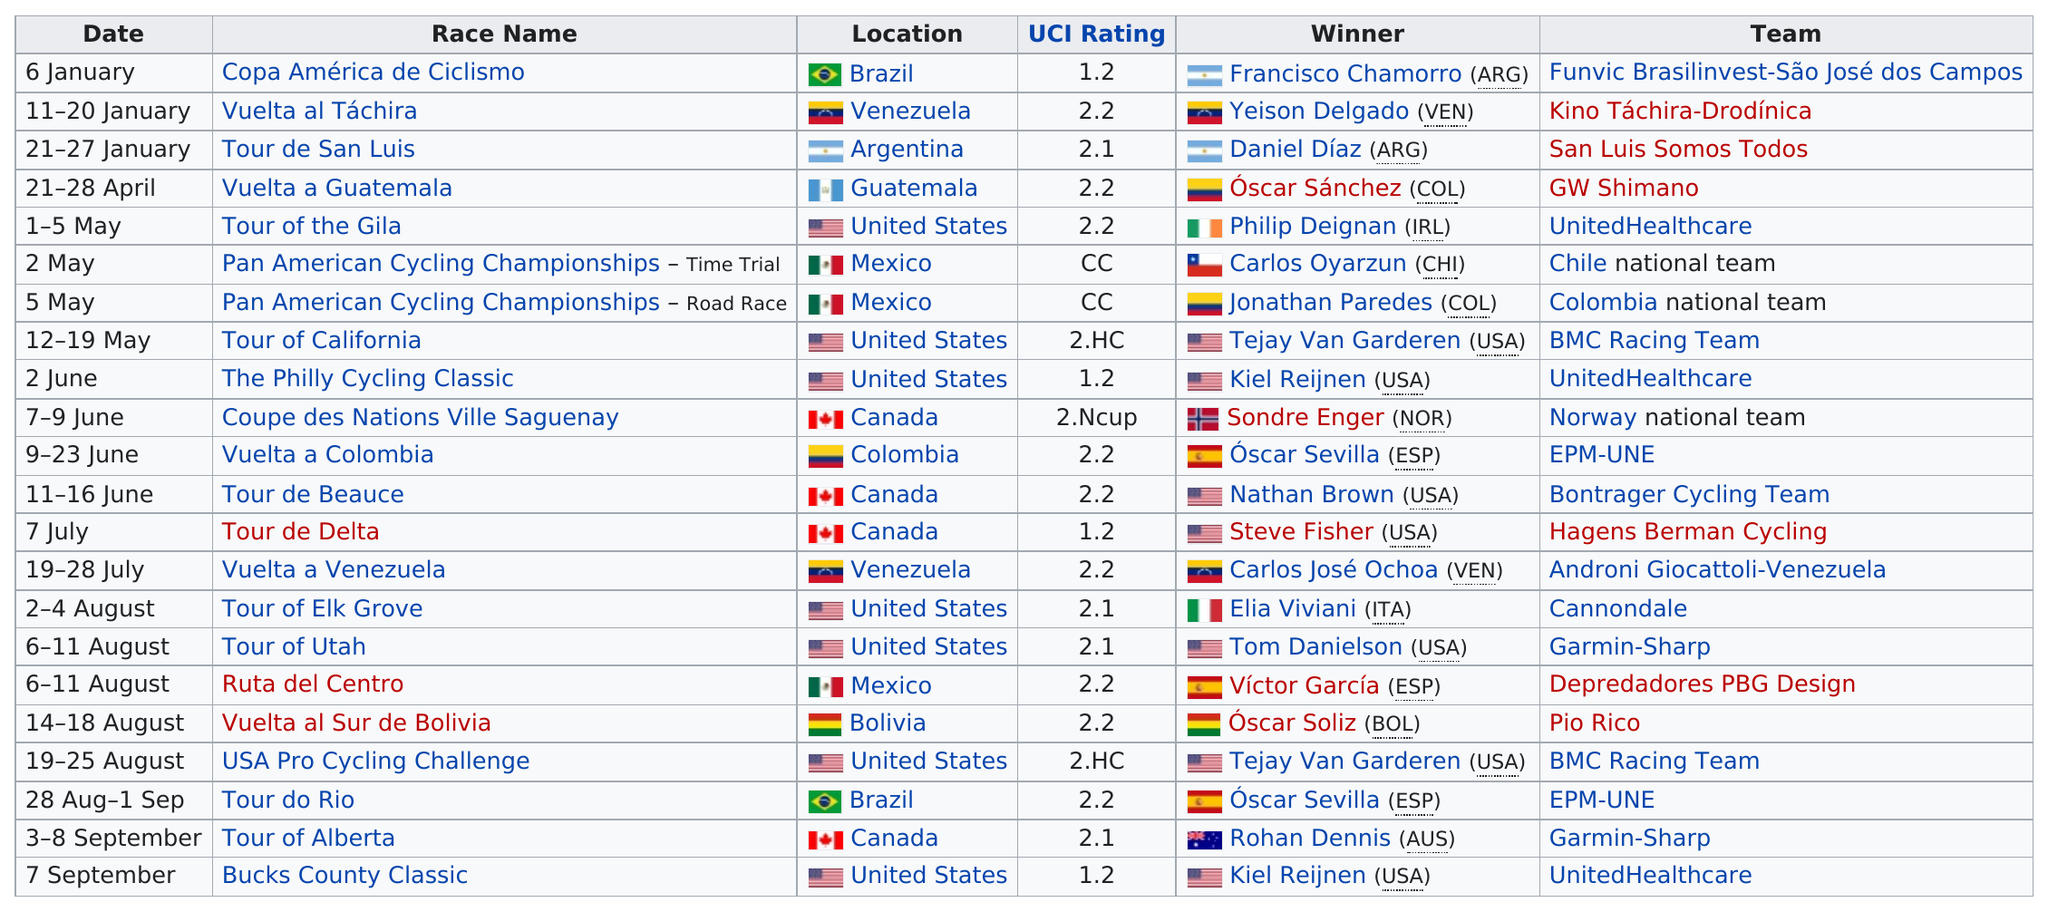List a handful of essential elements in this visual. Oscar Sevilla won more races in 2013 than Oscar Sanchez. Francisco Chamorro, representing Argentina, and his team, Funvic Brasilinvest-São José dos Campos, are the winners of the Copa América de Ciclismo race. Nathan Brown won his victory in the 2013 Tour de Beauce. The Tour de San Luis in 2013 had a higher UCI rating than the Tour of California that year. There are zero winners from Brazil. 